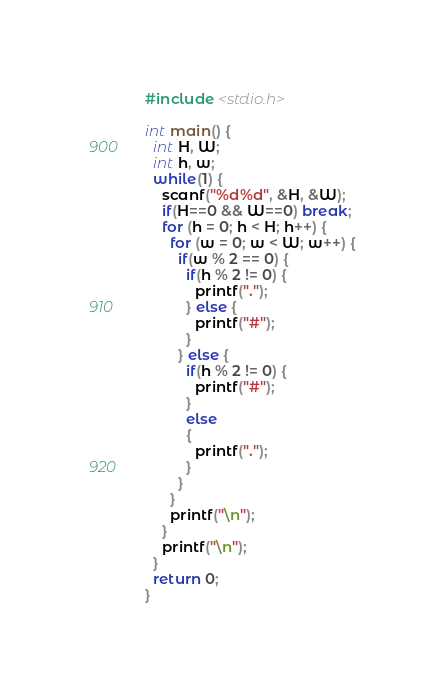<code> <loc_0><loc_0><loc_500><loc_500><_C_>#include <stdio.h>

int main() {
  int H, W;
  int h, w;
  while(1) {
    scanf("%d%d", &H, &W);
    if(H==0 && W==0) break;
    for (h = 0; h < H; h++) {
      for (w = 0; w < W; w++) {
        if(w % 2 == 0) {
          if(h % 2 != 0) {
            printf(".");
          } else {
            printf("#");
          }
        } else {
          if(h % 2 != 0) {
            printf("#");
          }
          else
          {
            printf(".");
          }
        }
      }
      printf("\n");
    }
    printf("\n");
  }
  return 0;
}

</code> 